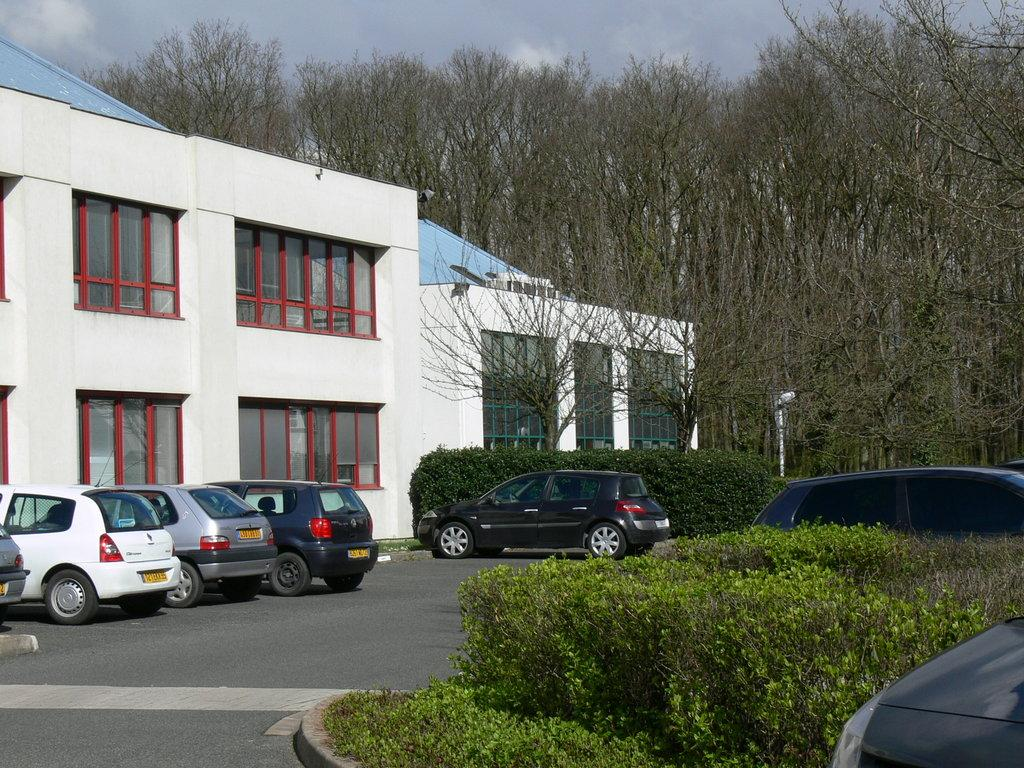What type of structures are visible in the image? There are buildings in the image. What feature do the buildings have? The buildings have windows. What type of vegetation can be seen in the image? There are trees and plants in the image. What object is present in the image that is not a building or vegetation? There is a pole in the image. What type of transportation is visible in the image? There are vehicles on the road in the image. What is the color of the sky in the image? The sky is blue and white in color. What type of bone is being used to cook in the oven in the image? There is no bone or oven present in the image; it features buildings, trees, a pole, vehicles, and a blue and white sky. 